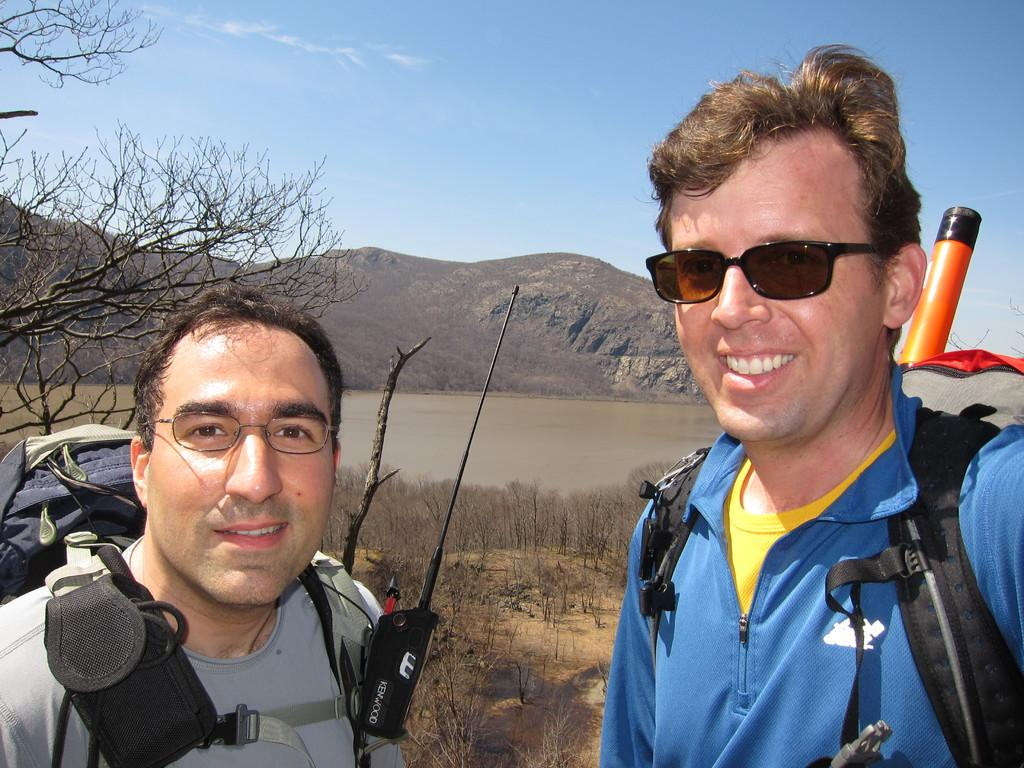How many men are in the image? There are two men in the image. What are the men wearing that is visible in the image? The men are wearing glasses (specs) in the image. What are the men carrying in the image? The men are carrying bags in the image. What expressions do the men have in the image? The men are smiling in the image. What can be seen in the background of the image? There are dried trees, a lake, and a hill in the background of the image. What is visible above the hill in the image? The sky is visible above the hill in the image. Where are the scissors located in the image? There are no scissors present in the image. What type of mailbox can be seen near the lake in the image? There is no mailbox present in the image; it only features two men, dried trees, a lake, a hill, and the sky. 